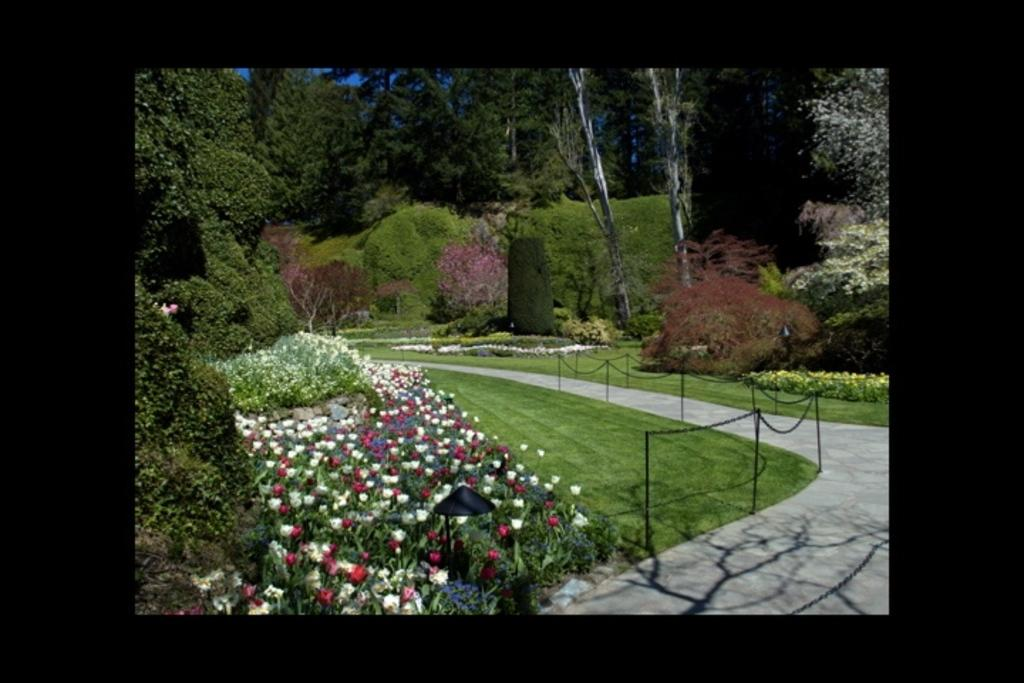What type of plants can be seen in the image? There are plants with flowers in the image. What other types of vegetation are present in the image? There are plants and trees on the grassland. What can be seen on the right side of the image? There is a path on the right side of the image. What surrounds the path in the image? There is a fence on both sides of the path. What is the main setting of the image? The grassland is visible in the image. Where is the shelf located in the image? There is no shelf present in the image. What type of hall can be seen in the image? There is no hall present in the image. 